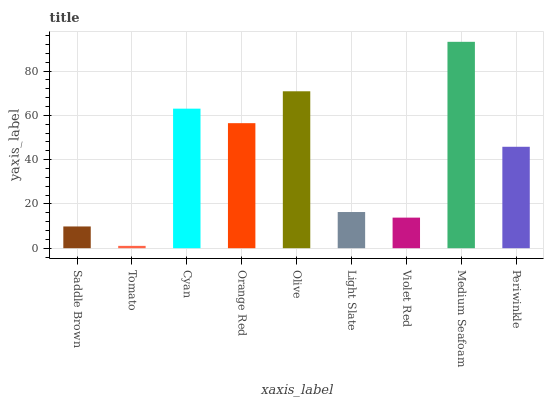Is Tomato the minimum?
Answer yes or no. Yes. Is Medium Seafoam the maximum?
Answer yes or no. Yes. Is Cyan the minimum?
Answer yes or no. No. Is Cyan the maximum?
Answer yes or no. No. Is Cyan greater than Tomato?
Answer yes or no. Yes. Is Tomato less than Cyan?
Answer yes or no. Yes. Is Tomato greater than Cyan?
Answer yes or no. No. Is Cyan less than Tomato?
Answer yes or no. No. Is Periwinkle the high median?
Answer yes or no. Yes. Is Periwinkle the low median?
Answer yes or no. Yes. Is Saddle Brown the high median?
Answer yes or no. No. Is Saddle Brown the low median?
Answer yes or no. No. 